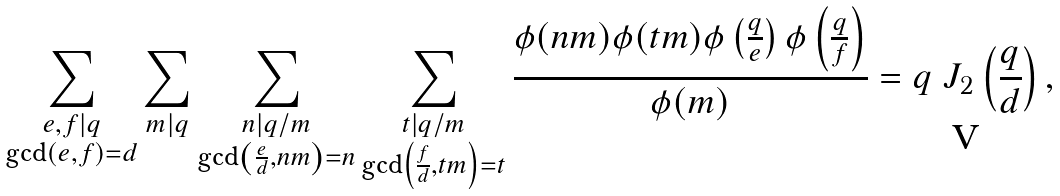Convert formula to latex. <formula><loc_0><loc_0><loc_500><loc_500>\sum _ { \substack { e , f | q \\ \gcd ( e , f ) = d } } \sum _ { m | q } \sum _ { \substack { n | q / m \\ \gcd \left ( \frac { e } { d } , n m \right ) = n } } \sum _ { \substack { t | q / m \\ \gcd \left ( \frac { f } { d } , t m \right ) = t } } \frac { \phi ( n m ) \phi ( t m ) \phi \left ( \frac { q } { e } \right ) \phi \left ( \frac { q } { f } \right ) } { \phi ( m ) } = q \ J _ { 2 } \left ( \frac { q } { d } \right ) ,</formula> 